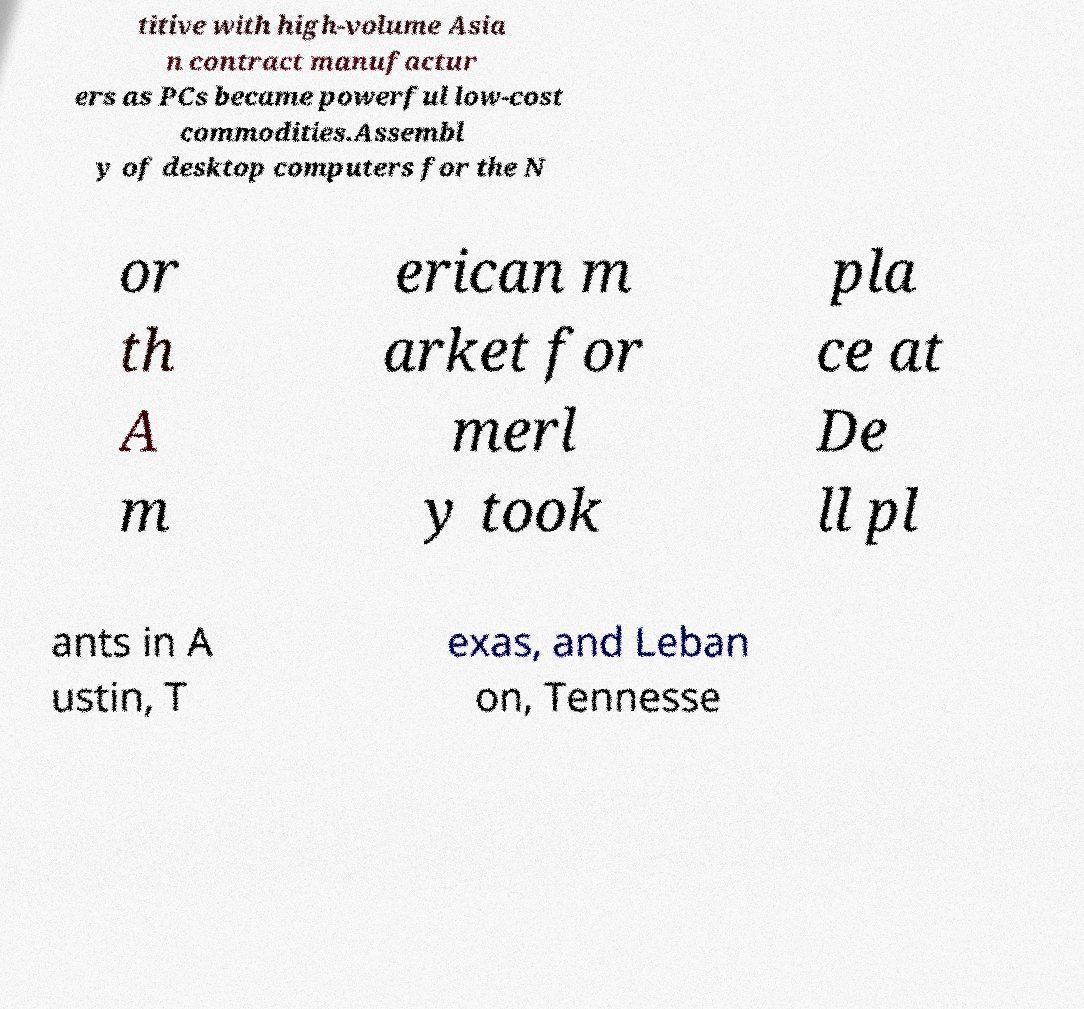Can you accurately transcribe the text from the provided image for me? titive with high-volume Asia n contract manufactur ers as PCs became powerful low-cost commodities.Assembl y of desktop computers for the N or th A m erican m arket for merl y took pla ce at De ll pl ants in A ustin, T exas, and Leban on, Tennesse 